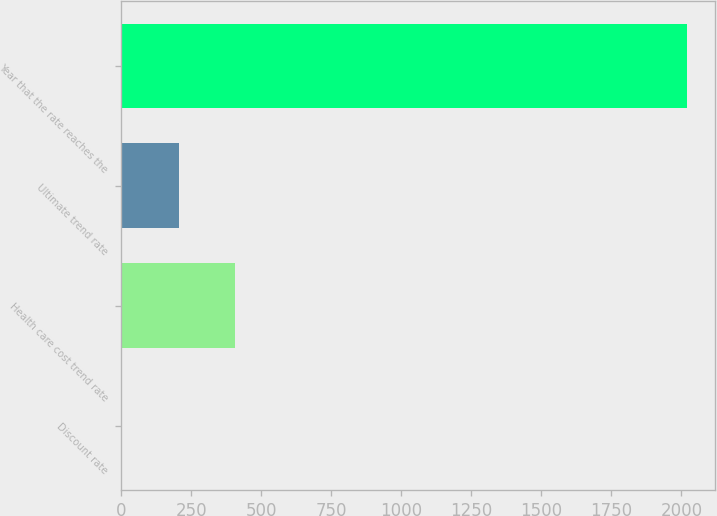Convert chart. <chart><loc_0><loc_0><loc_500><loc_500><bar_chart><fcel>Discount rate<fcel>Health care cost trend rate<fcel>Ultimate trend rate<fcel>Year that the rate reaches the<nl><fcel>3.9<fcel>406.72<fcel>205.31<fcel>2018<nl></chart> 